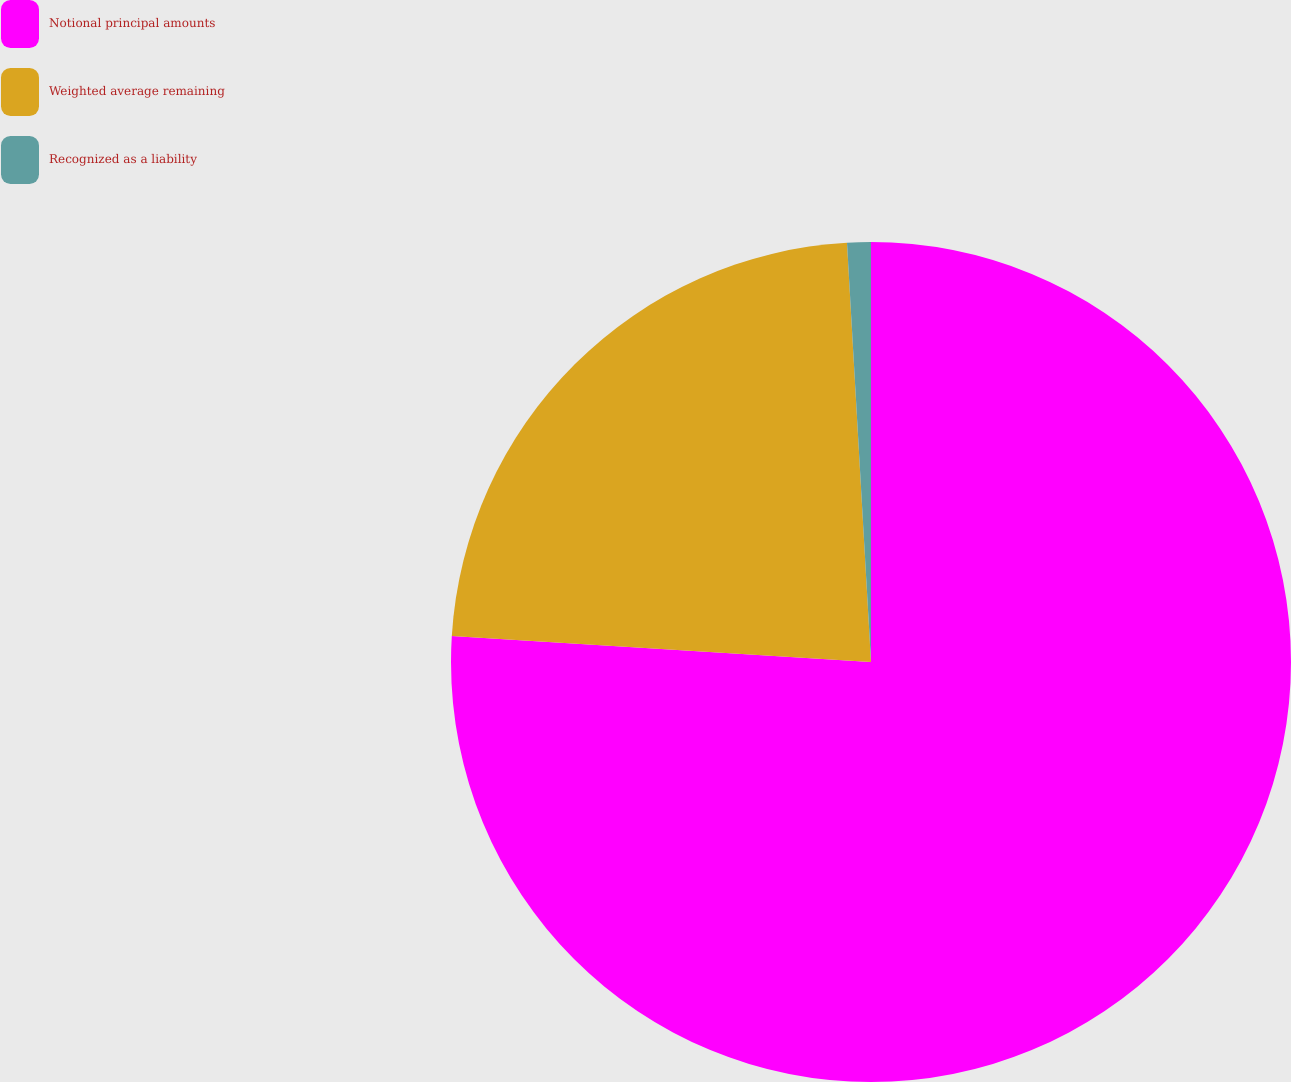Convert chart to OTSL. <chart><loc_0><loc_0><loc_500><loc_500><pie_chart><fcel>Notional principal amounts<fcel>Weighted average remaining<fcel>Recognized as a liability<nl><fcel>75.99%<fcel>23.1%<fcel>0.91%<nl></chart> 